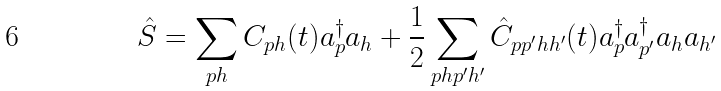Convert formula to latex. <formula><loc_0><loc_0><loc_500><loc_500>\hat { S } = \sum _ { p h } C _ { p h } ( t ) a ^ { \dagger } _ { p } a _ { h } + \frac { 1 } { 2 } \sum _ { p h p ^ { \prime } h ^ { \prime } } \hat { C } _ { p p ^ { \prime } h h ^ { \prime } } ( t ) a ^ { \dagger } _ { p } a ^ { \dagger } _ { p ^ { \prime } } a _ { h } a _ { h ^ { \prime } }</formula> 